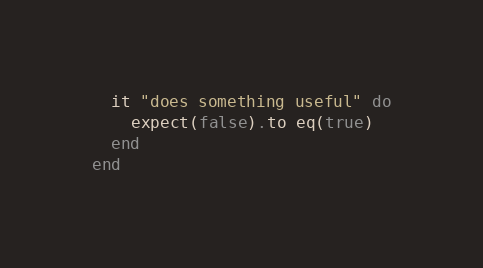<code> <loc_0><loc_0><loc_500><loc_500><_Ruby_>  it "does something useful" do
    expect(false).to eq(true)
  end
end
</code> 